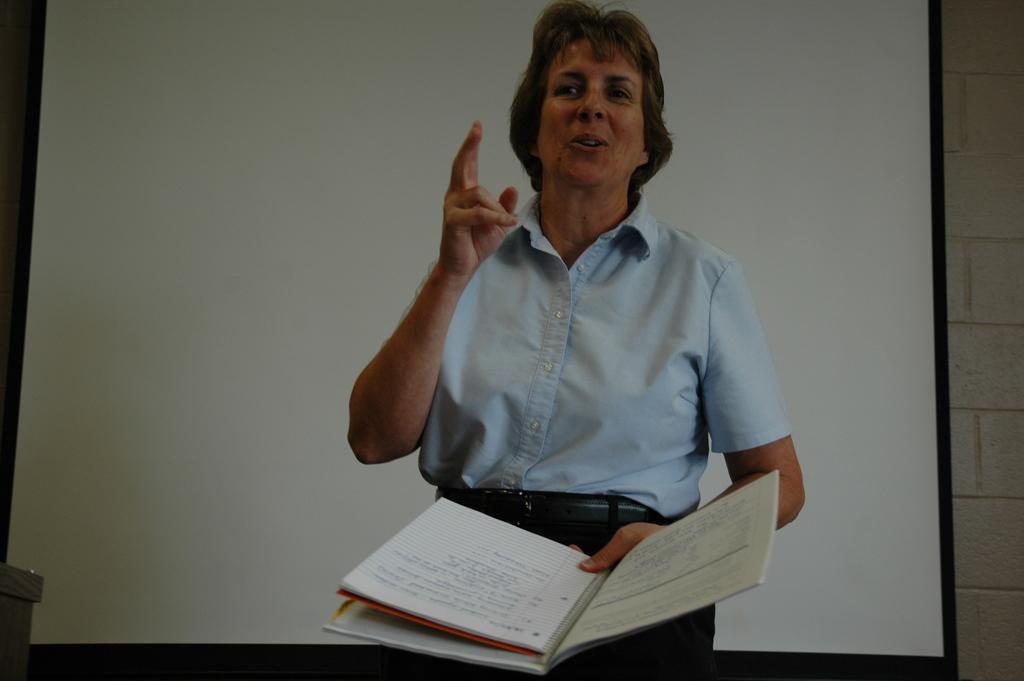Please provide a concise description of this image. In this image we can see a person holding a book and talking. In the background, we can see a projector screen and the wall. 